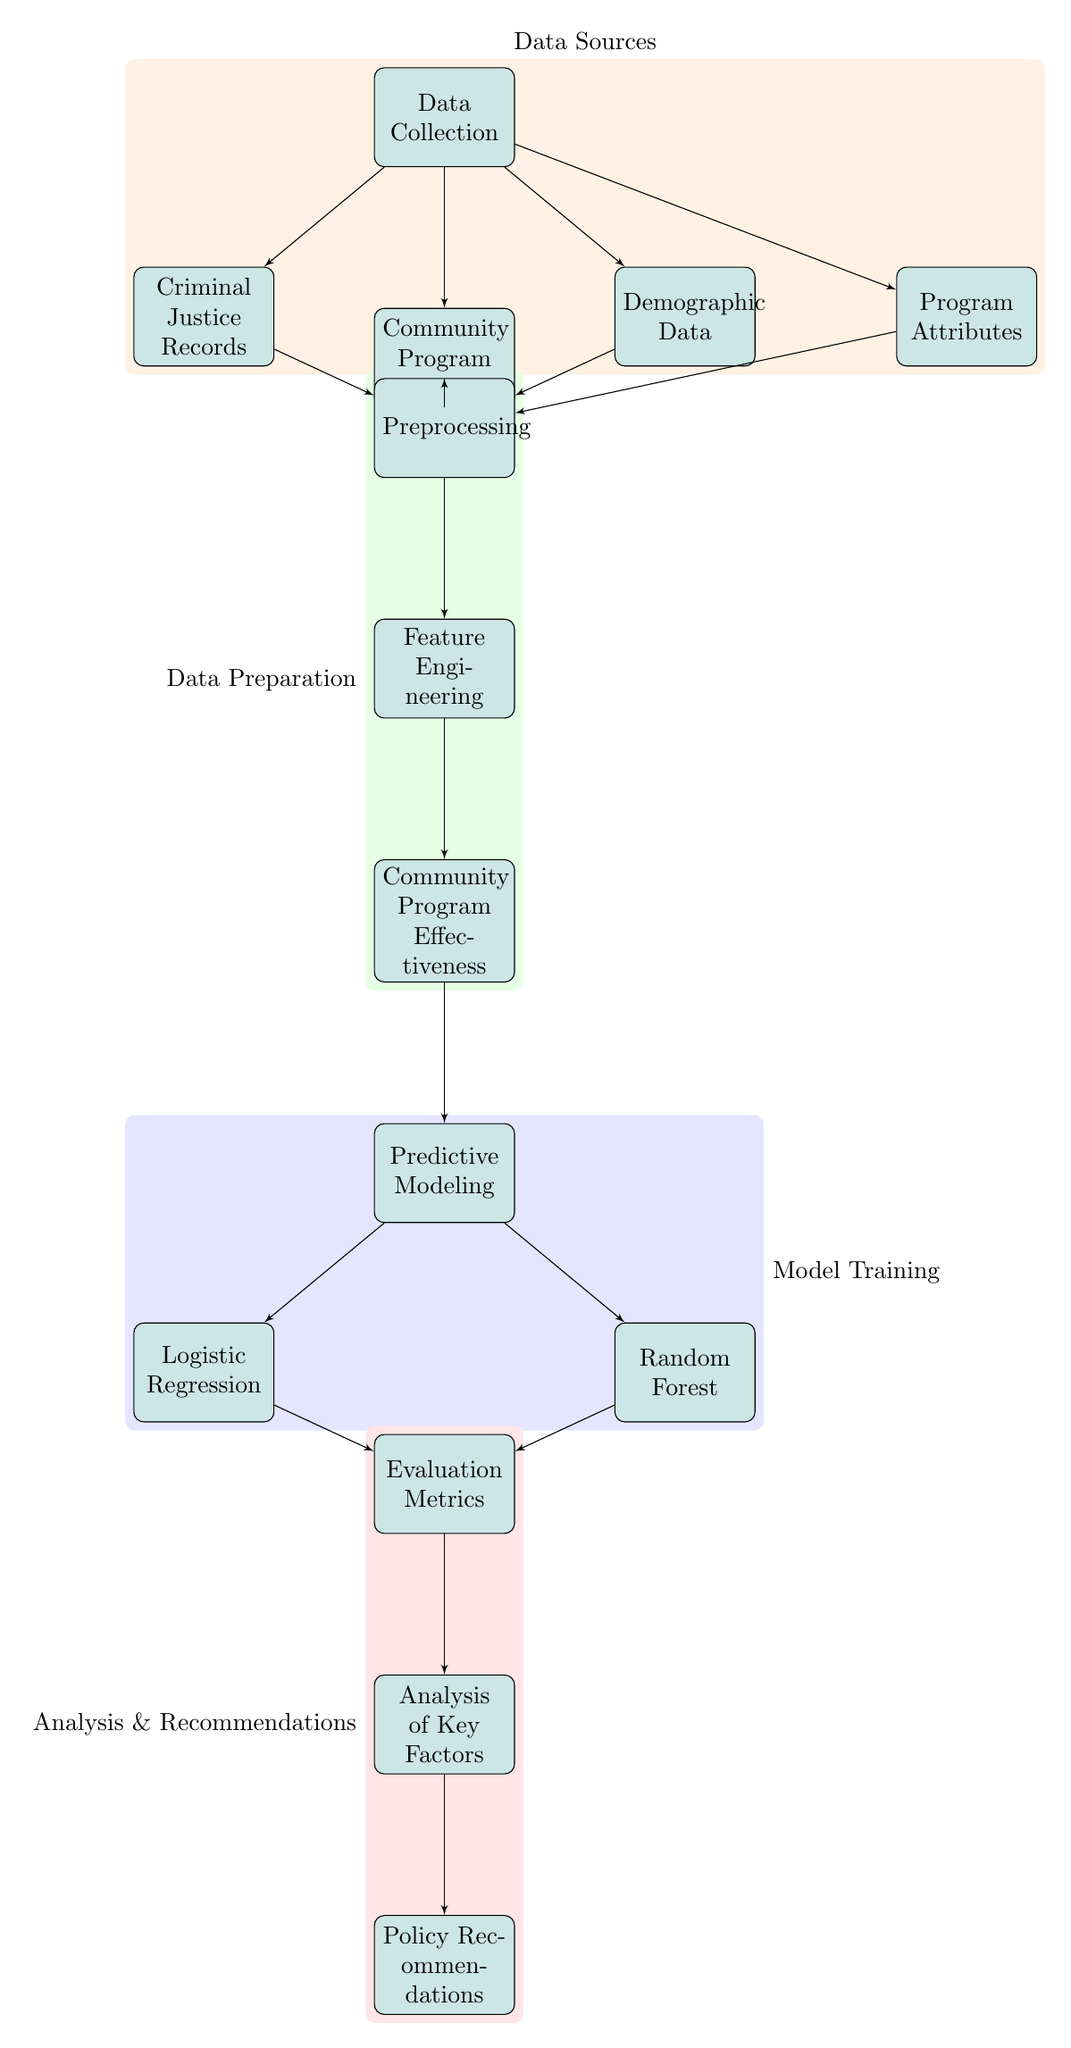What is the first step in the diagram? The first step in the diagram is labeled as "Data Collection," which is depicted at the top and acts as the initiating point for the process.
Answer: Data Collection How many modeling techniques are used in this diagram? The diagram displays two modeling techniques, which are "Logistic Regression" and "Random Forest," both branching from the "Predictive Modeling" node.
Answer: Two What data source is focused on community programs? The data source focused on community programs is labeled "Community Program Records," which is one of the nodes directly connected to the "Data Collection" node.
Answer: Community Program Records Which node connects "Feature Engineering" to "Community Program Effectiveness"? The connection from "Feature Engineering" to "Community Program Effectiveness" is directly from the "Feature Engineering" node leading downward to the "Community Program Effectiveness" node, indicating the flow of data processing.
Answer: Feature Engineering What is the purpose of the "Evaluation Metrics" node? The "Evaluation Metrics" node is intended to assess the outputs of the "Logistic Regression" and "Random Forest" models to understand their performance and effectiveness based on the predictions made from the previous levels.
Answer: Assess model performance How many total data sources are represented in the diagram? The total number of data sources represented includes four: "Criminal Justice Records," "Community Program Records," "Demographic Data," and "Program Attributes," all feeding into the "Data Collection" node.
Answer: Four What action follows after "Community Program Effectiveness"? The action that follows after "Community Program Effectiveness" in the diagram is "Predictive Modeling," indicating that once effectiveness is evaluated, the next step is to create predictive models based on that data.
Answer: Predictive Modeling Which analysis connects to the policy recommendations? The analysis that connects to the policy recommendations is labeled "Analysis of Key Factors," which directly leads to the "Policy Recommendations" node, suggesting that key findings influence policy decisions.
Answer: Analysis of Key Factors How many blocks are labeled as part of "Data Preparation"? Three blocks are labeled as part of "Data Preparation," which includes "Preprocessing," "Feature Engineering," and "Community Program Effectiveness."
Answer: Three What color represents the "Analysis & Recommendations" section in the diagram? The color representing the "Analysis & Recommendations" section is red, which is highlighted in the background layer of the diagram around the corresponding blocks.
Answer: Red 